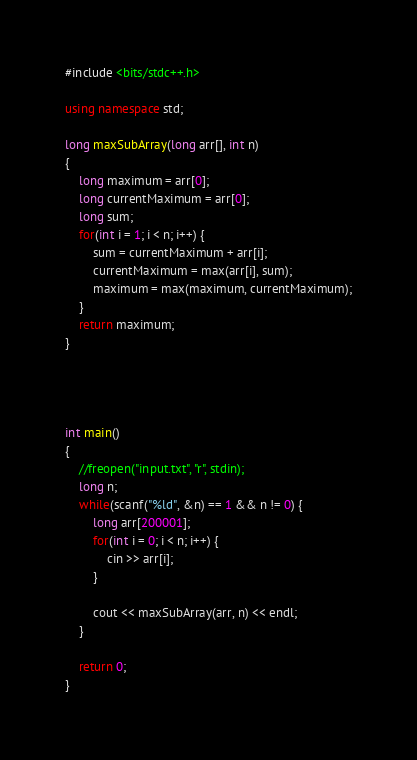Convert code to text. <code><loc_0><loc_0><loc_500><loc_500><_C++_>#include <bits/stdc++.h>

using namespace std;

long maxSubArray(long arr[], int n)
{
	long maximum = arr[0];
	long currentMaximum = arr[0];
	long sum;
	for(int i = 1; i < n; i++) {
		sum = currentMaximum + arr[i];
		currentMaximum = max(arr[i], sum);
		maximum = max(maximum, currentMaximum);
	}
	return maximum;
}




int main()
{
	//freopen("input.txt", "r", stdin);
	long n;
	while(scanf("%ld", &n) == 1 && n != 0) {
		long arr[200001];
		for(int i = 0; i < n; i++) {
			cin >> arr[i];
		}

		cout << maxSubArray(arr, n) << endl;
	}

	return 0;
}</code> 